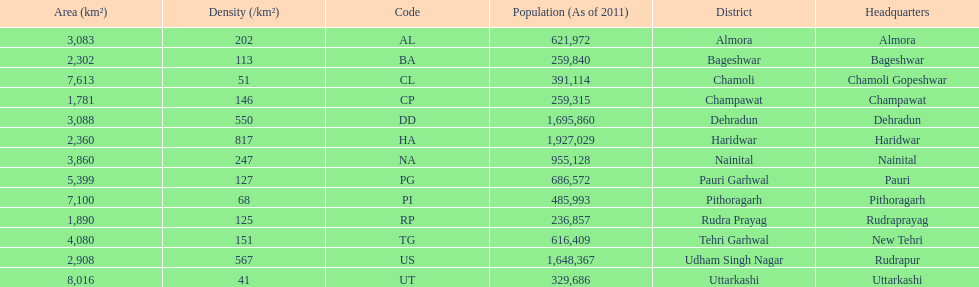What is the last code listed? UT. 